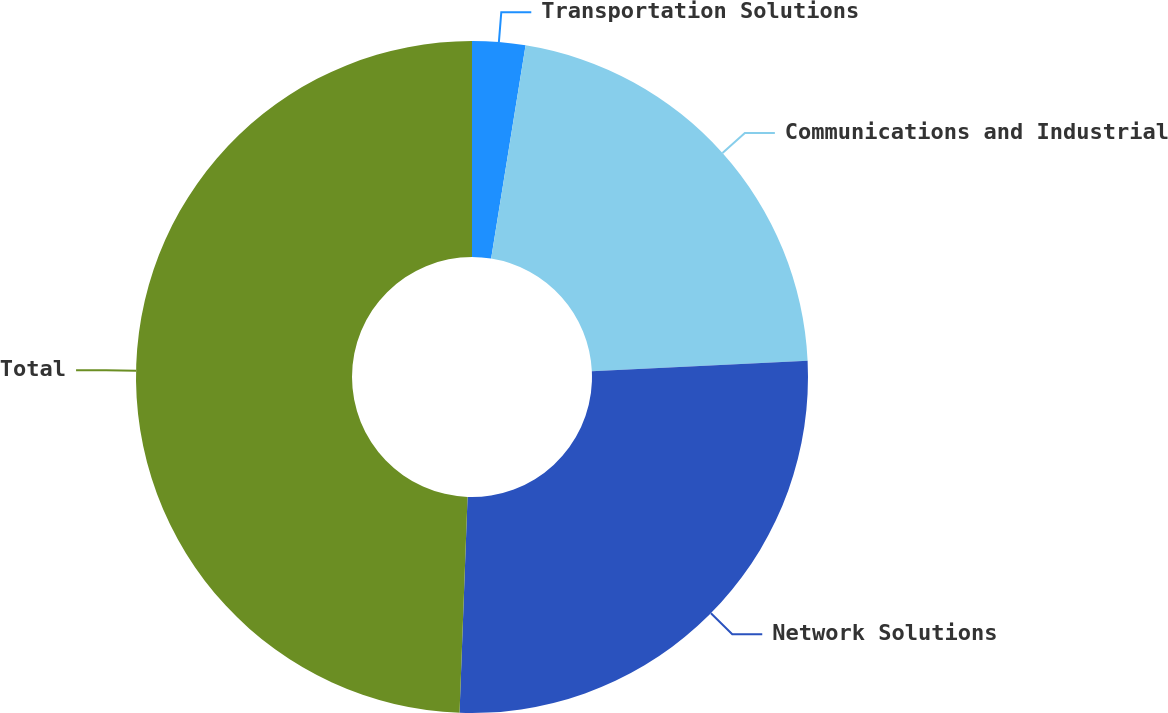Convert chart. <chart><loc_0><loc_0><loc_500><loc_500><pie_chart><fcel>Transportation Solutions<fcel>Communications and Industrial<fcel>Network Solutions<fcel>Total<nl><fcel>2.55%<fcel>21.68%<fcel>26.36%<fcel>49.41%<nl></chart> 